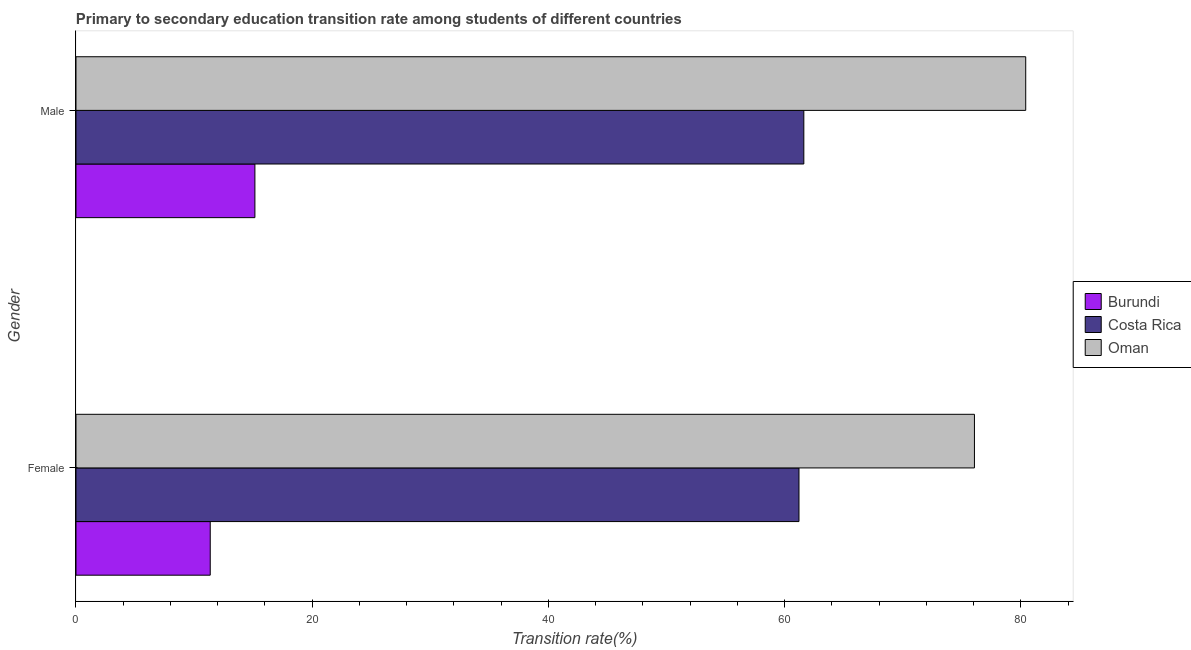How many different coloured bars are there?
Offer a very short reply. 3. Are the number of bars per tick equal to the number of legend labels?
Your answer should be compact. Yes. How many bars are there on the 2nd tick from the top?
Give a very brief answer. 3. What is the label of the 1st group of bars from the top?
Provide a short and direct response. Male. What is the transition rate among male students in Oman?
Offer a very short reply. 80.42. Across all countries, what is the maximum transition rate among female students?
Your answer should be compact. 76.08. Across all countries, what is the minimum transition rate among male students?
Provide a short and direct response. 15.15. In which country was the transition rate among female students maximum?
Make the answer very short. Oman. In which country was the transition rate among female students minimum?
Your response must be concise. Burundi. What is the total transition rate among female students in the graph?
Keep it short and to the point. 148.66. What is the difference between the transition rate among female students in Burundi and that in Costa Rica?
Your answer should be compact. -49.85. What is the difference between the transition rate among female students in Burundi and the transition rate among male students in Costa Rica?
Ensure brevity in your answer.  -50.26. What is the average transition rate among female students per country?
Provide a short and direct response. 49.55. What is the difference between the transition rate among female students and transition rate among male students in Costa Rica?
Keep it short and to the point. -0.41. What is the ratio of the transition rate among male students in Burundi to that in Costa Rica?
Make the answer very short. 0.25. Is the transition rate among male students in Oman less than that in Burundi?
Make the answer very short. No. What does the 1st bar from the top in Male represents?
Give a very brief answer. Oman. What does the 1st bar from the bottom in Male represents?
Your response must be concise. Burundi. How many countries are there in the graph?
Provide a succinct answer. 3. Are the values on the major ticks of X-axis written in scientific E-notation?
Offer a very short reply. No. Does the graph contain grids?
Provide a short and direct response. No. How many legend labels are there?
Your answer should be compact. 3. How are the legend labels stacked?
Ensure brevity in your answer.  Vertical. What is the title of the graph?
Provide a succinct answer. Primary to secondary education transition rate among students of different countries. Does "Bhutan" appear as one of the legend labels in the graph?
Provide a short and direct response. No. What is the label or title of the X-axis?
Make the answer very short. Transition rate(%). What is the label or title of the Y-axis?
Your response must be concise. Gender. What is the Transition rate(%) of Burundi in Female?
Give a very brief answer. 11.37. What is the Transition rate(%) of Costa Rica in Female?
Your answer should be compact. 61.22. What is the Transition rate(%) of Oman in Female?
Your answer should be compact. 76.08. What is the Transition rate(%) of Burundi in Male?
Keep it short and to the point. 15.15. What is the Transition rate(%) of Costa Rica in Male?
Give a very brief answer. 61.63. What is the Transition rate(%) of Oman in Male?
Offer a very short reply. 80.42. Across all Gender, what is the maximum Transition rate(%) of Burundi?
Ensure brevity in your answer.  15.15. Across all Gender, what is the maximum Transition rate(%) in Costa Rica?
Provide a short and direct response. 61.63. Across all Gender, what is the maximum Transition rate(%) in Oman?
Offer a terse response. 80.42. Across all Gender, what is the minimum Transition rate(%) of Burundi?
Make the answer very short. 11.37. Across all Gender, what is the minimum Transition rate(%) of Costa Rica?
Offer a very short reply. 61.22. Across all Gender, what is the minimum Transition rate(%) in Oman?
Your answer should be very brief. 76.08. What is the total Transition rate(%) in Burundi in the graph?
Offer a very short reply. 26.52. What is the total Transition rate(%) of Costa Rica in the graph?
Make the answer very short. 122.85. What is the total Transition rate(%) of Oman in the graph?
Offer a very short reply. 156.5. What is the difference between the Transition rate(%) in Burundi in Female and that in Male?
Offer a terse response. -3.78. What is the difference between the Transition rate(%) of Costa Rica in Female and that in Male?
Provide a succinct answer. -0.41. What is the difference between the Transition rate(%) of Oman in Female and that in Male?
Ensure brevity in your answer.  -4.34. What is the difference between the Transition rate(%) of Burundi in Female and the Transition rate(%) of Costa Rica in Male?
Your answer should be very brief. -50.26. What is the difference between the Transition rate(%) in Burundi in Female and the Transition rate(%) in Oman in Male?
Offer a terse response. -69.05. What is the difference between the Transition rate(%) of Costa Rica in Female and the Transition rate(%) of Oman in Male?
Offer a terse response. -19.2. What is the average Transition rate(%) of Burundi per Gender?
Ensure brevity in your answer.  13.26. What is the average Transition rate(%) in Costa Rica per Gender?
Give a very brief answer. 61.42. What is the average Transition rate(%) in Oman per Gender?
Your answer should be very brief. 78.25. What is the difference between the Transition rate(%) of Burundi and Transition rate(%) of Costa Rica in Female?
Offer a terse response. -49.85. What is the difference between the Transition rate(%) of Burundi and Transition rate(%) of Oman in Female?
Your response must be concise. -64.71. What is the difference between the Transition rate(%) of Costa Rica and Transition rate(%) of Oman in Female?
Ensure brevity in your answer.  -14.86. What is the difference between the Transition rate(%) in Burundi and Transition rate(%) in Costa Rica in Male?
Ensure brevity in your answer.  -46.48. What is the difference between the Transition rate(%) of Burundi and Transition rate(%) of Oman in Male?
Give a very brief answer. -65.27. What is the difference between the Transition rate(%) of Costa Rica and Transition rate(%) of Oman in Male?
Your answer should be very brief. -18.79. What is the ratio of the Transition rate(%) in Burundi in Female to that in Male?
Ensure brevity in your answer.  0.75. What is the ratio of the Transition rate(%) of Costa Rica in Female to that in Male?
Make the answer very short. 0.99. What is the ratio of the Transition rate(%) in Oman in Female to that in Male?
Offer a very short reply. 0.95. What is the difference between the highest and the second highest Transition rate(%) in Burundi?
Offer a terse response. 3.78. What is the difference between the highest and the second highest Transition rate(%) in Costa Rica?
Provide a short and direct response. 0.41. What is the difference between the highest and the second highest Transition rate(%) of Oman?
Provide a short and direct response. 4.34. What is the difference between the highest and the lowest Transition rate(%) of Burundi?
Offer a terse response. 3.78. What is the difference between the highest and the lowest Transition rate(%) in Costa Rica?
Provide a succinct answer. 0.41. What is the difference between the highest and the lowest Transition rate(%) of Oman?
Your answer should be compact. 4.34. 